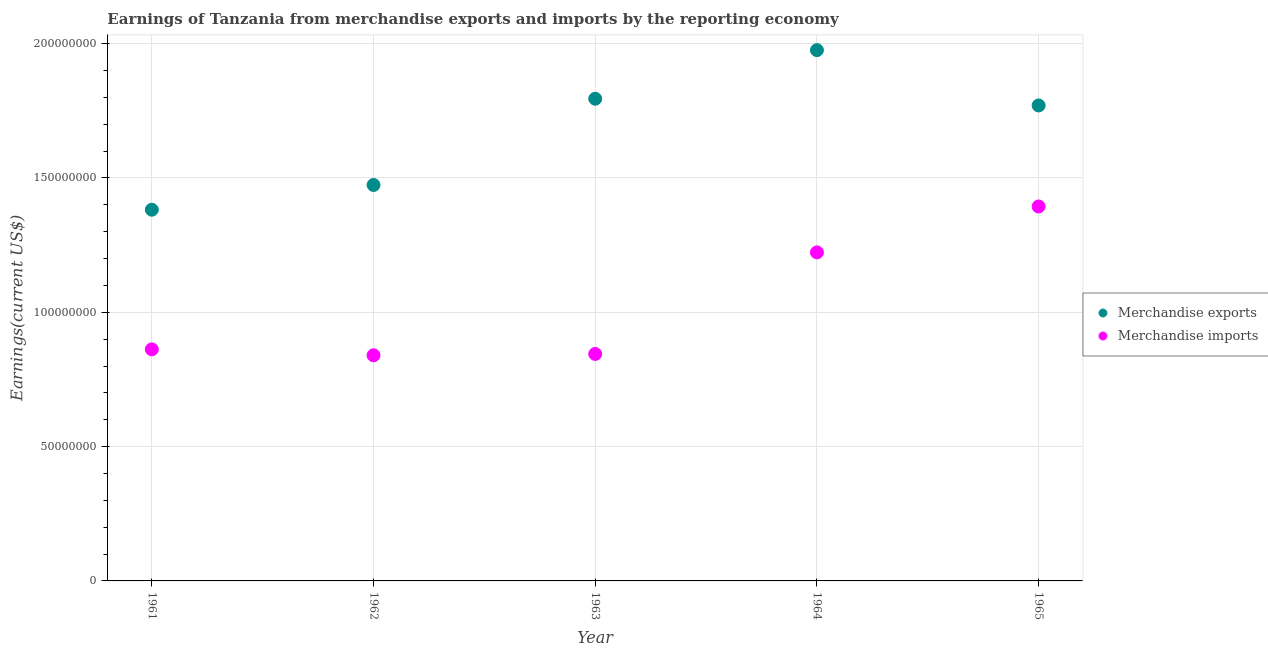What is the earnings from merchandise exports in 1963?
Your answer should be very brief. 1.80e+08. Across all years, what is the maximum earnings from merchandise imports?
Give a very brief answer. 1.39e+08. Across all years, what is the minimum earnings from merchandise exports?
Your answer should be very brief. 1.38e+08. In which year was the earnings from merchandise exports maximum?
Your response must be concise. 1964. In which year was the earnings from merchandise exports minimum?
Make the answer very short. 1961. What is the total earnings from merchandise imports in the graph?
Keep it short and to the point. 5.16e+08. What is the difference between the earnings from merchandise exports in 1961 and that in 1962?
Ensure brevity in your answer.  -9.20e+06. What is the difference between the earnings from merchandise imports in 1963 and the earnings from merchandise exports in 1962?
Provide a short and direct response. -6.29e+07. What is the average earnings from merchandise exports per year?
Keep it short and to the point. 1.68e+08. In the year 1965, what is the difference between the earnings from merchandise imports and earnings from merchandise exports?
Provide a short and direct response. -3.76e+07. In how many years, is the earnings from merchandise exports greater than 40000000 US$?
Your answer should be compact. 5. What is the ratio of the earnings from merchandise imports in 1961 to that in 1965?
Provide a succinct answer. 0.62. Is the difference between the earnings from merchandise exports in 1963 and 1964 greater than the difference between the earnings from merchandise imports in 1963 and 1964?
Provide a succinct answer. Yes. What is the difference between the highest and the second highest earnings from merchandise exports?
Keep it short and to the point. 1.81e+07. What is the difference between the highest and the lowest earnings from merchandise exports?
Your answer should be very brief. 5.94e+07. In how many years, is the earnings from merchandise exports greater than the average earnings from merchandise exports taken over all years?
Ensure brevity in your answer.  3. Does the earnings from merchandise imports monotonically increase over the years?
Ensure brevity in your answer.  No. Is the earnings from merchandise imports strictly greater than the earnings from merchandise exports over the years?
Keep it short and to the point. No. How many years are there in the graph?
Your answer should be compact. 5. Where does the legend appear in the graph?
Provide a short and direct response. Center right. What is the title of the graph?
Ensure brevity in your answer.  Earnings of Tanzania from merchandise exports and imports by the reporting economy. Does "Mobile cellular" appear as one of the legend labels in the graph?
Keep it short and to the point. No. What is the label or title of the Y-axis?
Your answer should be very brief. Earnings(current US$). What is the Earnings(current US$) of Merchandise exports in 1961?
Offer a terse response. 1.38e+08. What is the Earnings(current US$) in Merchandise imports in 1961?
Your answer should be very brief. 8.62e+07. What is the Earnings(current US$) of Merchandise exports in 1962?
Provide a succinct answer. 1.47e+08. What is the Earnings(current US$) in Merchandise imports in 1962?
Offer a very short reply. 8.40e+07. What is the Earnings(current US$) of Merchandise exports in 1963?
Offer a very short reply. 1.80e+08. What is the Earnings(current US$) in Merchandise imports in 1963?
Offer a terse response. 8.45e+07. What is the Earnings(current US$) in Merchandise exports in 1964?
Provide a short and direct response. 1.98e+08. What is the Earnings(current US$) of Merchandise imports in 1964?
Offer a very short reply. 1.22e+08. What is the Earnings(current US$) in Merchandise exports in 1965?
Offer a terse response. 1.77e+08. What is the Earnings(current US$) of Merchandise imports in 1965?
Your answer should be very brief. 1.39e+08. Across all years, what is the maximum Earnings(current US$) in Merchandise exports?
Ensure brevity in your answer.  1.98e+08. Across all years, what is the maximum Earnings(current US$) in Merchandise imports?
Offer a terse response. 1.39e+08. Across all years, what is the minimum Earnings(current US$) of Merchandise exports?
Provide a succinct answer. 1.38e+08. Across all years, what is the minimum Earnings(current US$) of Merchandise imports?
Provide a succinct answer. 8.40e+07. What is the total Earnings(current US$) of Merchandise exports in the graph?
Provide a succinct answer. 8.40e+08. What is the total Earnings(current US$) in Merchandise imports in the graph?
Your response must be concise. 5.16e+08. What is the difference between the Earnings(current US$) in Merchandise exports in 1961 and that in 1962?
Make the answer very short. -9.20e+06. What is the difference between the Earnings(current US$) in Merchandise imports in 1961 and that in 1962?
Provide a short and direct response. 2.20e+06. What is the difference between the Earnings(current US$) of Merchandise exports in 1961 and that in 1963?
Offer a very short reply. -4.13e+07. What is the difference between the Earnings(current US$) of Merchandise imports in 1961 and that in 1963?
Give a very brief answer. 1.70e+06. What is the difference between the Earnings(current US$) of Merchandise exports in 1961 and that in 1964?
Your response must be concise. -5.94e+07. What is the difference between the Earnings(current US$) of Merchandise imports in 1961 and that in 1964?
Your answer should be compact. -3.61e+07. What is the difference between the Earnings(current US$) of Merchandise exports in 1961 and that in 1965?
Your response must be concise. -3.88e+07. What is the difference between the Earnings(current US$) of Merchandise imports in 1961 and that in 1965?
Give a very brief answer. -5.32e+07. What is the difference between the Earnings(current US$) of Merchandise exports in 1962 and that in 1963?
Your answer should be compact. -3.21e+07. What is the difference between the Earnings(current US$) of Merchandise imports in 1962 and that in 1963?
Offer a very short reply. -5.00e+05. What is the difference between the Earnings(current US$) in Merchandise exports in 1962 and that in 1964?
Offer a very short reply. -5.02e+07. What is the difference between the Earnings(current US$) of Merchandise imports in 1962 and that in 1964?
Give a very brief answer. -3.83e+07. What is the difference between the Earnings(current US$) in Merchandise exports in 1962 and that in 1965?
Offer a very short reply. -2.96e+07. What is the difference between the Earnings(current US$) of Merchandise imports in 1962 and that in 1965?
Provide a succinct answer. -5.54e+07. What is the difference between the Earnings(current US$) of Merchandise exports in 1963 and that in 1964?
Offer a very short reply. -1.81e+07. What is the difference between the Earnings(current US$) of Merchandise imports in 1963 and that in 1964?
Give a very brief answer. -3.78e+07. What is the difference between the Earnings(current US$) of Merchandise exports in 1963 and that in 1965?
Your response must be concise. 2.50e+06. What is the difference between the Earnings(current US$) in Merchandise imports in 1963 and that in 1965?
Your answer should be compact. -5.49e+07. What is the difference between the Earnings(current US$) in Merchandise exports in 1964 and that in 1965?
Your answer should be very brief. 2.06e+07. What is the difference between the Earnings(current US$) of Merchandise imports in 1964 and that in 1965?
Offer a very short reply. -1.71e+07. What is the difference between the Earnings(current US$) of Merchandise exports in 1961 and the Earnings(current US$) of Merchandise imports in 1962?
Give a very brief answer. 5.42e+07. What is the difference between the Earnings(current US$) in Merchandise exports in 1961 and the Earnings(current US$) in Merchandise imports in 1963?
Your answer should be very brief. 5.37e+07. What is the difference between the Earnings(current US$) in Merchandise exports in 1961 and the Earnings(current US$) in Merchandise imports in 1964?
Your response must be concise. 1.59e+07. What is the difference between the Earnings(current US$) in Merchandise exports in 1961 and the Earnings(current US$) in Merchandise imports in 1965?
Keep it short and to the point. -1.20e+06. What is the difference between the Earnings(current US$) of Merchandise exports in 1962 and the Earnings(current US$) of Merchandise imports in 1963?
Provide a succinct answer. 6.29e+07. What is the difference between the Earnings(current US$) of Merchandise exports in 1962 and the Earnings(current US$) of Merchandise imports in 1964?
Offer a very short reply. 2.51e+07. What is the difference between the Earnings(current US$) in Merchandise exports in 1962 and the Earnings(current US$) in Merchandise imports in 1965?
Make the answer very short. 8.00e+06. What is the difference between the Earnings(current US$) in Merchandise exports in 1963 and the Earnings(current US$) in Merchandise imports in 1964?
Offer a terse response. 5.72e+07. What is the difference between the Earnings(current US$) of Merchandise exports in 1963 and the Earnings(current US$) of Merchandise imports in 1965?
Provide a succinct answer. 4.01e+07. What is the difference between the Earnings(current US$) in Merchandise exports in 1964 and the Earnings(current US$) in Merchandise imports in 1965?
Give a very brief answer. 5.82e+07. What is the average Earnings(current US$) in Merchandise exports per year?
Give a very brief answer. 1.68e+08. What is the average Earnings(current US$) of Merchandise imports per year?
Keep it short and to the point. 1.03e+08. In the year 1961, what is the difference between the Earnings(current US$) of Merchandise exports and Earnings(current US$) of Merchandise imports?
Your answer should be very brief. 5.20e+07. In the year 1962, what is the difference between the Earnings(current US$) in Merchandise exports and Earnings(current US$) in Merchandise imports?
Make the answer very short. 6.34e+07. In the year 1963, what is the difference between the Earnings(current US$) in Merchandise exports and Earnings(current US$) in Merchandise imports?
Your answer should be very brief. 9.50e+07. In the year 1964, what is the difference between the Earnings(current US$) of Merchandise exports and Earnings(current US$) of Merchandise imports?
Provide a short and direct response. 7.53e+07. In the year 1965, what is the difference between the Earnings(current US$) in Merchandise exports and Earnings(current US$) in Merchandise imports?
Give a very brief answer. 3.76e+07. What is the ratio of the Earnings(current US$) of Merchandise exports in 1961 to that in 1962?
Offer a terse response. 0.94. What is the ratio of the Earnings(current US$) in Merchandise imports in 1961 to that in 1962?
Provide a succinct answer. 1.03. What is the ratio of the Earnings(current US$) of Merchandise exports in 1961 to that in 1963?
Make the answer very short. 0.77. What is the ratio of the Earnings(current US$) of Merchandise imports in 1961 to that in 1963?
Offer a terse response. 1.02. What is the ratio of the Earnings(current US$) of Merchandise exports in 1961 to that in 1964?
Your response must be concise. 0.7. What is the ratio of the Earnings(current US$) in Merchandise imports in 1961 to that in 1964?
Your answer should be very brief. 0.7. What is the ratio of the Earnings(current US$) in Merchandise exports in 1961 to that in 1965?
Offer a terse response. 0.78. What is the ratio of the Earnings(current US$) in Merchandise imports in 1961 to that in 1965?
Your answer should be very brief. 0.62. What is the ratio of the Earnings(current US$) of Merchandise exports in 1962 to that in 1963?
Provide a short and direct response. 0.82. What is the ratio of the Earnings(current US$) of Merchandise imports in 1962 to that in 1963?
Provide a short and direct response. 0.99. What is the ratio of the Earnings(current US$) in Merchandise exports in 1962 to that in 1964?
Offer a terse response. 0.75. What is the ratio of the Earnings(current US$) in Merchandise imports in 1962 to that in 1964?
Ensure brevity in your answer.  0.69. What is the ratio of the Earnings(current US$) of Merchandise exports in 1962 to that in 1965?
Provide a succinct answer. 0.83. What is the ratio of the Earnings(current US$) of Merchandise imports in 1962 to that in 1965?
Your response must be concise. 0.6. What is the ratio of the Earnings(current US$) in Merchandise exports in 1963 to that in 1964?
Provide a short and direct response. 0.91. What is the ratio of the Earnings(current US$) of Merchandise imports in 1963 to that in 1964?
Ensure brevity in your answer.  0.69. What is the ratio of the Earnings(current US$) of Merchandise exports in 1963 to that in 1965?
Your answer should be very brief. 1.01. What is the ratio of the Earnings(current US$) of Merchandise imports in 1963 to that in 1965?
Provide a succinct answer. 0.61. What is the ratio of the Earnings(current US$) of Merchandise exports in 1964 to that in 1965?
Your answer should be very brief. 1.12. What is the ratio of the Earnings(current US$) in Merchandise imports in 1964 to that in 1965?
Keep it short and to the point. 0.88. What is the difference between the highest and the second highest Earnings(current US$) of Merchandise exports?
Give a very brief answer. 1.81e+07. What is the difference between the highest and the second highest Earnings(current US$) in Merchandise imports?
Give a very brief answer. 1.71e+07. What is the difference between the highest and the lowest Earnings(current US$) in Merchandise exports?
Offer a very short reply. 5.94e+07. What is the difference between the highest and the lowest Earnings(current US$) in Merchandise imports?
Provide a short and direct response. 5.54e+07. 